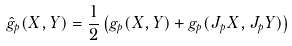Convert formula to latex. <formula><loc_0><loc_0><loc_500><loc_500>\hat { g } _ { p } ( X , Y ) = \frac { 1 } { 2 } \left ( g _ { p } ( X , Y ) + g _ { p } ( J _ { p } X , J _ { p } Y ) \right )</formula> 